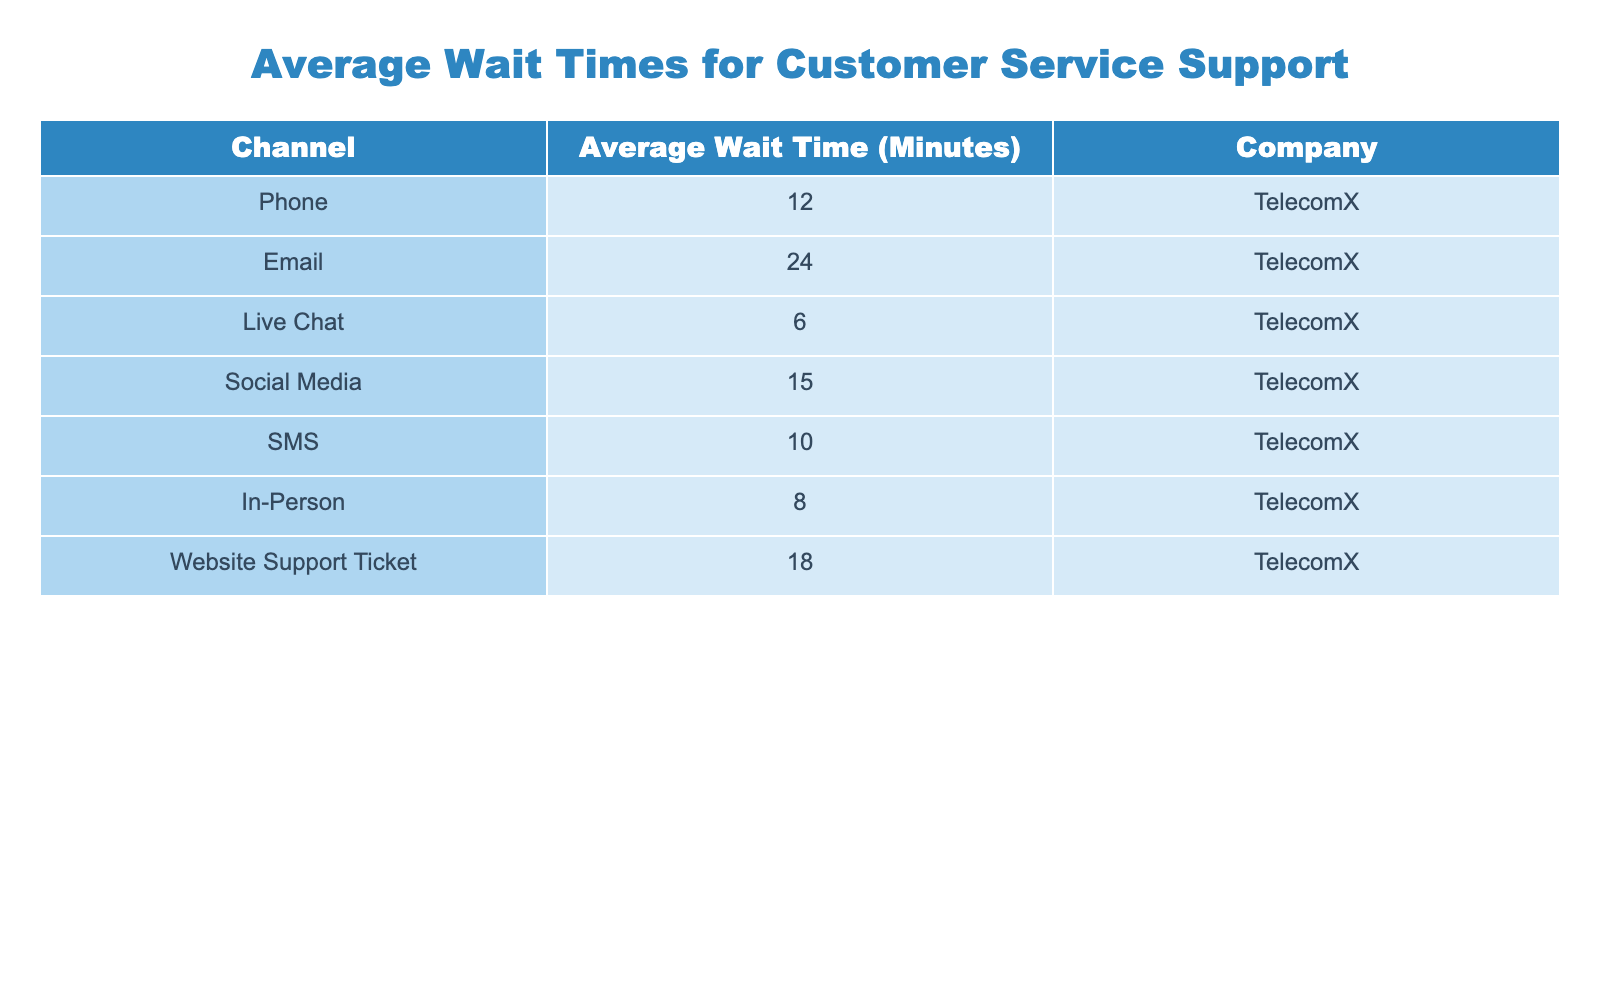What is the average wait time for customer service support through the live chat channel? According to the table, the average wait time for the live chat channel is 6 minutes.
Answer: 6 minutes Which channel has the longest average wait time? In the table, the channel with the longest average wait time is the email channel, which has an average wait time of 24 minutes.
Answer: Email What is the average wait time for customer service support across all channels? To find the average, sum all the average wait times: 12 (Phone) + 24 (Email) + 6 (Live Chat) + 15 (Social Media) + 10 (SMS) + 8 (In-Person) + 18 (Website) = 93 minutes. There are 7 channels, so the average wait time is 93/7 = approximately 13.29 minutes.
Answer: Approximately 13.29 minutes Is the average wait time for the SMS channel less than 15 minutes? The average wait time for the SMS channel is 10 minutes, which is less than 15 minutes. Therefore, the answer is yes.
Answer: Yes What is the difference in average wait time between the phone and email channels? The average wait time for the phone channel is 12 minutes, while the average for the email channel is 24 minutes. The difference is 24 - 12 = 12 minutes.
Answer: 12 minutes Which channel has a shorter wait time, social media or in-person? The average wait time for social media is 15 minutes, while for in-person it is 8 minutes. Since 8 is less than 15, the in-person channel has a shorter wait time.
Answer: In-Person If a customer reaches out via SMS and waits for 10 minutes, how does that compare to the average wait time for SMS? The average wait time for SMS is also 10 minutes. Since the customer waited the exact average time, they are neither below nor above the average.
Answer: Equal to average What is the median average wait time among all channels? To find the median, first list the average wait times in order: 6 (Live Chat), 8 (In-Person), 10 (SMS), 12 (Phone), 15 (Social Media), 18 (Website), 24 (Email), which gives us a sorted list of 6, 8, 10, 12, 15, 18, 24. The median is the average of the 3rd and 4th values: (10 + 12) / 2 = 11 minutes.
Answer: 11 minutes 